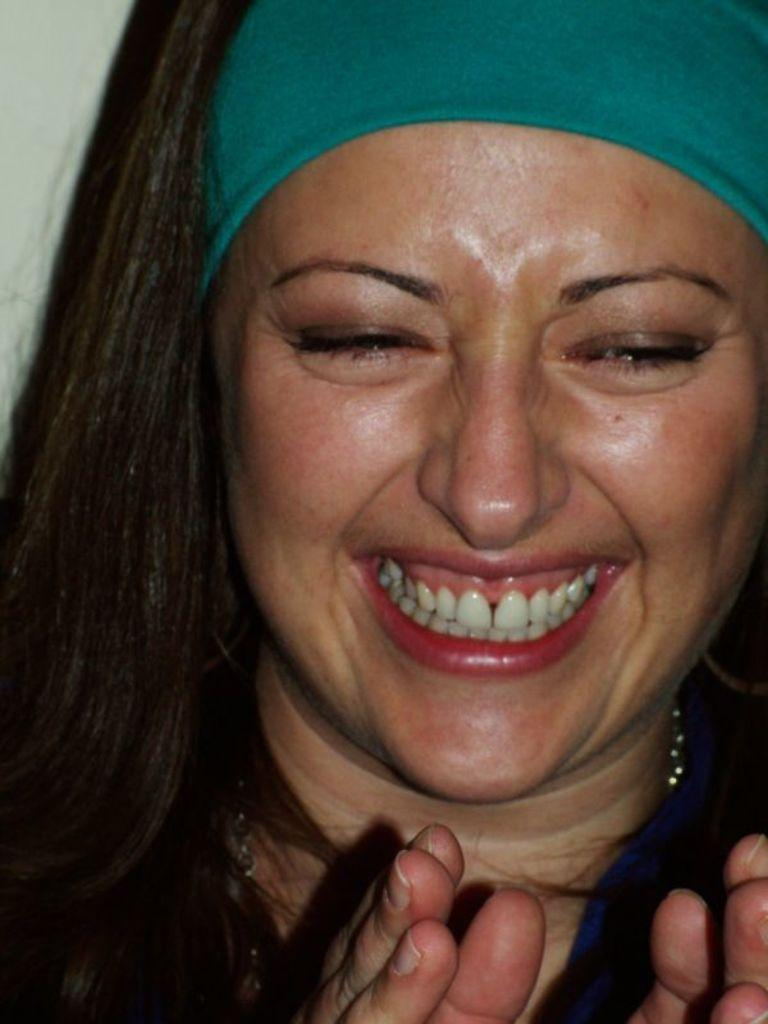Who is present in the image? There is a woman in the image. What is the woman's facial expression? The woman is smiling. What accessory is the woman wearing? The woman is wearing a hairband. What is the woman arguing about with the lawyer in the image? There is no lawyer or argument present in the image; it only features a woman who is smiling and wearing a hairband. 